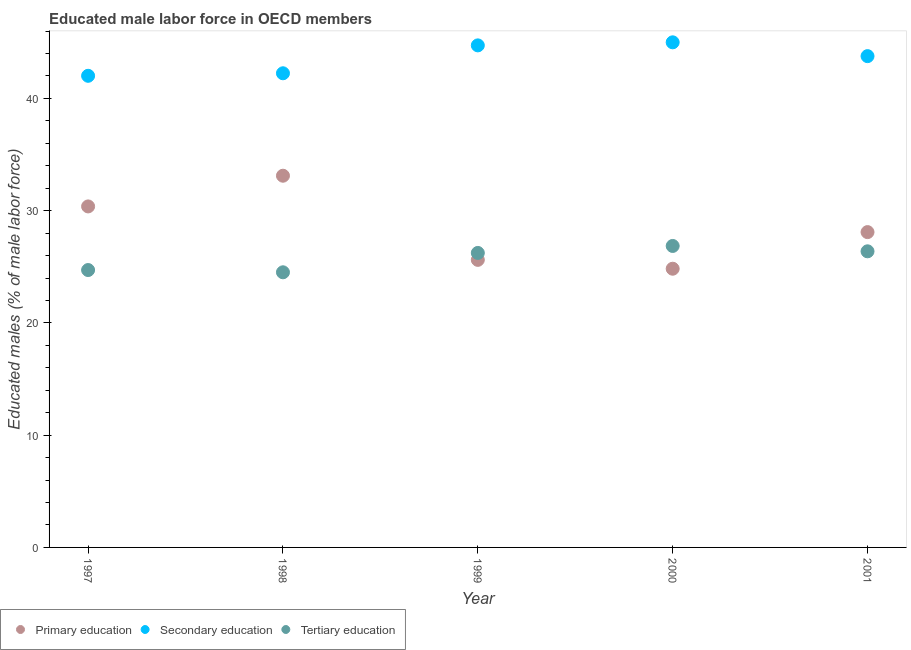What is the percentage of male labor force who received primary education in 1998?
Your answer should be very brief. 33.11. Across all years, what is the maximum percentage of male labor force who received secondary education?
Your response must be concise. 45. Across all years, what is the minimum percentage of male labor force who received tertiary education?
Ensure brevity in your answer.  24.51. What is the total percentage of male labor force who received tertiary education in the graph?
Offer a terse response. 128.69. What is the difference between the percentage of male labor force who received tertiary education in 1998 and that in 2000?
Provide a short and direct response. -2.35. What is the difference between the percentage of male labor force who received primary education in 2001 and the percentage of male labor force who received secondary education in 1999?
Offer a very short reply. -16.63. What is the average percentage of male labor force who received secondary education per year?
Your response must be concise. 43.55. In the year 2000, what is the difference between the percentage of male labor force who received secondary education and percentage of male labor force who received tertiary education?
Make the answer very short. 18.14. What is the ratio of the percentage of male labor force who received tertiary education in 1999 to that in 2000?
Ensure brevity in your answer.  0.98. What is the difference between the highest and the second highest percentage of male labor force who received tertiary education?
Keep it short and to the point. 0.48. What is the difference between the highest and the lowest percentage of male labor force who received primary education?
Make the answer very short. 8.28. In how many years, is the percentage of male labor force who received secondary education greater than the average percentage of male labor force who received secondary education taken over all years?
Offer a very short reply. 3. How many dotlines are there?
Offer a very short reply. 3. How many years are there in the graph?
Keep it short and to the point. 5. Does the graph contain any zero values?
Your answer should be very brief. No. Does the graph contain grids?
Provide a succinct answer. No. Where does the legend appear in the graph?
Provide a short and direct response. Bottom left. How many legend labels are there?
Offer a terse response. 3. How are the legend labels stacked?
Offer a very short reply. Horizontal. What is the title of the graph?
Your answer should be compact. Educated male labor force in OECD members. Does "Self-employed" appear as one of the legend labels in the graph?
Provide a succinct answer. No. What is the label or title of the X-axis?
Give a very brief answer. Year. What is the label or title of the Y-axis?
Provide a succinct answer. Educated males (% of male labor force). What is the Educated males (% of male labor force) of Primary education in 1997?
Your response must be concise. 30.38. What is the Educated males (% of male labor force) of Secondary education in 1997?
Your answer should be very brief. 42.01. What is the Educated males (% of male labor force) in Tertiary education in 1997?
Provide a succinct answer. 24.71. What is the Educated males (% of male labor force) of Primary education in 1998?
Your answer should be very brief. 33.11. What is the Educated males (% of male labor force) in Secondary education in 1998?
Provide a succinct answer. 42.24. What is the Educated males (% of male labor force) in Tertiary education in 1998?
Make the answer very short. 24.51. What is the Educated males (% of male labor force) in Primary education in 1999?
Offer a very short reply. 25.62. What is the Educated males (% of male labor force) in Secondary education in 1999?
Your response must be concise. 44.72. What is the Educated males (% of male labor force) of Tertiary education in 1999?
Keep it short and to the point. 26.23. What is the Educated males (% of male labor force) of Primary education in 2000?
Offer a very short reply. 24.83. What is the Educated males (% of male labor force) in Secondary education in 2000?
Make the answer very short. 45. What is the Educated males (% of male labor force) of Tertiary education in 2000?
Ensure brevity in your answer.  26.85. What is the Educated males (% of male labor force) in Primary education in 2001?
Offer a very short reply. 28.09. What is the Educated males (% of male labor force) in Secondary education in 2001?
Provide a short and direct response. 43.76. What is the Educated males (% of male labor force) of Tertiary education in 2001?
Offer a terse response. 26.38. Across all years, what is the maximum Educated males (% of male labor force) in Primary education?
Your response must be concise. 33.11. Across all years, what is the maximum Educated males (% of male labor force) in Secondary education?
Your answer should be very brief. 45. Across all years, what is the maximum Educated males (% of male labor force) in Tertiary education?
Offer a very short reply. 26.85. Across all years, what is the minimum Educated males (% of male labor force) of Primary education?
Your answer should be very brief. 24.83. Across all years, what is the minimum Educated males (% of male labor force) in Secondary education?
Make the answer very short. 42.01. Across all years, what is the minimum Educated males (% of male labor force) in Tertiary education?
Your answer should be very brief. 24.51. What is the total Educated males (% of male labor force) of Primary education in the graph?
Provide a short and direct response. 142.02. What is the total Educated males (% of male labor force) of Secondary education in the graph?
Ensure brevity in your answer.  217.73. What is the total Educated males (% of male labor force) of Tertiary education in the graph?
Provide a succinct answer. 128.69. What is the difference between the Educated males (% of male labor force) in Primary education in 1997 and that in 1998?
Your answer should be very brief. -2.73. What is the difference between the Educated males (% of male labor force) of Secondary education in 1997 and that in 1998?
Your answer should be compact. -0.22. What is the difference between the Educated males (% of male labor force) in Tertiary education in 1997 and that in 1998?
Your answer should be compact. 0.2. What is the difference between the Educated males (% of male labor force) of Primary education in 1997 and that in 1999?
Provide a short and direct response. 4.76. What is the difference between the Educated males (% of male labor force) of Secondary education in 1997 and that in 1999?
Make the answer very short. -2.71. What is the difference between the Educated males (% of male labor force) of Tertiary education in 1997 and that in 1999?
Offer a terse response. -1.52. What is the difference between the Educated males (% of male labor force) in Primary education in 1997 and that in 2000?
Make the answer very short. 5.55. What is the difference between the Educated males (% of male labor force) in Secondary education in 1997 and that in 2000?
Your response must be concise. -2.98. What is the difference between the Educated males (% of male labor force) of Tertiary education in 1997 and that in 2000?
Give a very brief answer. -2.14. What is the difference between the Educated males (% of male labor force) of Primary education in 1997 and that in 2001?
Provide a short and direct response. 2.29. What is the difference between the Educated males (% of male labor force) in Secondary education in 1997 and that in 2001?
Offer a very short reply. -1.75. What is the difference between the Educated males (% of male labor force) in Tertiary education in 1997 and that in 2001?
Offer a terse response. -1.67. What is the difference between the Educated males (% of male labor force) in Primary education in 1998 and that in 1999?
Offer a terse response. 7.5. What is the difference between the Educated males (% of male labor force) in Secondary education in 1998 and that in 1999?
Ensure brevity in your answer.  -2.49. What is the difference between the Educated males (% of male labor force) in Tertiary education in 1998 and that in 1999?
Ensure brevity in your answer.  -1.72. What is the difference between the Educated males (% of male labor force) in Primary education in 1998 and that in 2000?
Offer a very short reply. 8.28. What is the difference between the Educated males (% of male labor force) of Secondary education in 1998 and that in 2000?
Ensure brevity in your answer.  -2.76. What is the difference between the Educated males (% of male labor force) in Tertiary education in 1998 and that in 2000?
Your response must be concise. -2.35. What is the difference between the Educated males (% of male labor force) of Primary education in 1998 and that in 2001?
Ensure brevity in your answer.  5.02. What is the difference between the Educated males (% of male labor force) in Secondary education in 1998 and that in 2001?
Your answer should be compact. -1.53. What is the difference between the Educated males (% of male labor force) in Tertiary education in 1998 and that in 2001?
Make the answer very short. -1.87. What is the difference between the Educated males (% of male labor force) of Primary education in 1999 and that in 2000?
Your response must be concise. 0.79. What is the difference between the Educated males (% of male labor force) of Secondary education in 1999 and that in 2000?
Give a very brief answer. -0.27. What is the difference between the Educated males (% of male labor force) in Tertiary education in 1999 and that in 2000?
Offer a very short reply. -0.62. What is the difference between the Educated males (% of male labor force) in Primary education in 1999 and that in 2001?
Give a very brief answer. -2.47. What is the difference between the Educated males (% of male labor force) in Secondary education in 1999 and that in 2001?
Make the answer very short. 0.96. What is the difference between the Educated males (% of male labor force) in Tertiary education in 1999 and that in 2001?
Make the answer very short. -0.14. What is the difference between the Educated males (% of male labor force) in Primary education in 2000 and that in 2001?
Provide a short and direct response. -3.26. What is the difference between the Educated males (% of male labor force) in Secondary education in 2000 and that in 2001?
Your answer should be very brief. 1.23. What is the difference between the Educated males (% of male labor force) in Tertiary education in 2000 and that in 2001?
Offer a terse response. 0.48. What is the difference between the Educated males (% of male labor force) of Primary education in 1997 and the Educated males (% of male labor force) of Secondary education in 1998?
Your response must be concise. -11.86. What is the difference between the Educated males (% of male labor force) of Primary education in 1997 and the Educated males (% of male labor force) of Tertiary education in 1998?
Your answer should be very brief. 5.87. What is the difference between the Educated males (% of male labor force) in Secondary education in 1997 and the Educated males (% of male labor force) in Tertiary education in 1998?
Your answer should be very brief. 17.5. What is the difference between the Educated males (% of male labor force) in Primary education in 1997 and the Educated males (% of male labor force) in Secondary education in 1999?
Offer a very short reply. -14.35. What is the difference between the Educated males (% of male labor force) in Primary education in 1997 and the Educated males (% of male labor force) in Tertiary education in 1999?
Provide a succinct answer. 4.14. What is the difference between the Educated males (% of male labor force) in Secondary education in 1997 and the Educated males (% of male labor force) in Tertiary education in 1999?
Provide a succinct answer. 15.78. What is the difference between the Educated males (% of male labor force) in Primary education in 1997 and the Educated males (% of male labor force) in Secondary education in 2000?
Keep it short and to the point. -14.62. What is the difference between the Educated males (% of male labor force) in Primary education in 1997 and the Educated males (% of male labor force) in Tertiary education in 2000?
Your response must be concise. 3.52. What is the difference between the Educated males (% of male labor force) in Secondary education in 1997 and the Educated males (% of male labor force) in Tertiary education in 2000?
Offer a very short reply. 15.16. What is the difference between the Educated males (% of male labor force) in Primary education in 1997 and the Educated males (% of male labor force) in Secondary education in 2001?
Your response must be concise. -13.39. What is the difference between the Educated males (% of male labor force) of Primary education in 1997 and the Educated males (% of male labor force) of Tertiary education in 2001?
Ensure brevity in your answer.  4. What is the difference between the Educated males (% of male labor force) of Secondary education in 1997 and the Educated males (% of male labor force) of Tertiary education in 2001?
Your answer should be very brief. 15.63. What is the difference between the Educated males (% of male labor force) in Primary education in 1998 and the Educated males (% of male labor force) in Secondary education in 1999?
Keep it short and to the point. -11.61. What is the difference between the Educated males (% of male labor force) in Primary education in 1998 and the Educated males (% of male labor force) in Tertiary education in 1999?
Ensure brevity in your answer.  6.88. What is the difference between the Educated males (% of male labor force) of Secondary education in 1998 and the Educated males (% of male labor force) of Tertiary education in 1999?
Your response must be concise. 16. What is the difference between the Educated males (% of male labor force) in Primary education in 1998 and the Educated males (% of male labor force) in Secondary education in 2000?
Your response must be concise. -11.88. What is the difference between the Educated males (% of male labor force) in Primary education in 1998 and the Educated males (% of male labor force) in Tertiary education in 2000?
Offer a very short reply. 6.26. What is the difference between the Educated males (% of male labor force) in Secondary education in 1998 and the Educated males (% of male labor force) in Tertiary education in 2000?
Offer a terse response. 15.38. What is the difference between the Educated males (% of male labor force) of Primary education in 1998 and the Educated males (% of male labor force) of Secondary education in 2001?
Your answer should be compact. -10.65. What is the difference between the Educated males (% of male labor force) of Primary education in 1998 and the Educated males (% of male labor force) of Tertiary education in 2001?
Provide a succinct answer. 6.73. What is the difference between the Educated males (% of male labor force) of Secondary education in 1998 and the Educated males (% of male labor force) of Tertiary education in 2001?
Make the answer very short. 15.86. What is the difference between the Educated males (% of male labor force) of Primary education in 1999 and the Educated males (% of male labor force) of Secondary education in 2000?
Provide a short and direct response. -19.38. What is the difference between the Educated males (% of male labor force) of Primary education in 1999 and the Educated males (% of male labor force) of Tertiary education in 2000?
Your answer should be very brief. -1.24. What is the difference between the Educated males (% of male labor force) of Secondary education in 1999 and the Educated males (% of male labor force) of Tertiary education in 2000?
Keep it short and to the point. 17.87. What is the difference between the Educated males (% of male labor force) in Primary education in 1999 and the Educated males (% of male labor force) in Secondary education in 2001?
Offer a very short reply. -18.15. What is the difference between the Educated males (% of male labor force) in Primary education in 1999 and the Educated males (% of male labor force) in Tertiary education in 2001?
Your answer should be compact. -0.76. What is the difference between the Educated males (% of male labor force) of Secondary education in 1999 and the Educated males (% of male labor force) of Tertiary education in 2001?
Offer a very short reply. 18.34. What is the difference between the Educated males (% of male labor force) of Primary education in 2000 and the Educated males (% of male labor force) of Secondary education in 2001?
Offer a very short reply. -18.94. What is the difference between the Educated males (% of male labor force) of Primary education in 2000 and the Educated males (% of male labor force) of Tertiary education in 2001?
Your answer should be compact. -1.55. What is the difference between the Educated males (% of male labor force) of Secondary education in 2000 and the Educated males (% of male labor force) of Tertiary education in 2001?
Offer a terse response. 18.62. What is the average Educated males (% of male labor force) of Primary education per year?
Ensure brevity in your answer.  28.4. What is the average Educated males (% of male labor force) in Secondary education per year?
Ensure brevity in your answer.  43.55. What is the average Educated males (% of male labor force) in Tertiary education per year?
Make the answer very short. 25.74. In the year 1997, what is the difference between the Educated males (% of male labor force) of Primary education and Educated males (% of male labor force) of Secondary education?
Provide a succinct answer. -11.64. In the year 1997, what is the difference between the Educated males (% of male labor force) in Primary education and Educated males (% of male labor force) in Tertiary education?
Your answer should be compact. 5.67. In the year 1997, what is the difference between the Educated males (% of male labor force) in Secondary education and Educated males (% of male labor force) in Tertiary education?
Your answer should be very brief. 17.3. In the year 1998, what is the difference between the Educated males (% of male labor force) in Primary education and Educated males (% of male labor force) in Secondary education?
Your answer should be compact. -9.13. In the year 1998, what is the difference between the Educated males (% of male labor force) in Primary education and Educated males (% of male labor force) in Tertiary education?
Your response must be concise. 8.6. In the year 1998, what is the difference between the Educated males (% of male labor force) in Secondary education and Educated males (% of male labor force) in Tertiary education?
Offer a terse response. 17.73. In the year 1999, what is the difference between the Educated males (% of male labor force) in Primary education and Educated males (% of male labor force) in Secondary education?
Ensure brevity in your answer.  -19.11. In the year 1999, what is the difference between the Educated males (% of male labor force) of Primary education and Educated males (% of male labor force) of Tertiary education?
Offer a very short reply. -0.62. In the year 1999, what is the difference between the Educated males (% of male labor force) of Secondary education and Educated males (% of male labor force) of Tertiary education?
Your answer should be compact. 18.49. In the year 2000, what is the difference between the Educated males (% of male labor force) of Primary education and Educated males (% of male labor force) of Secondary education?
Your answer should be very brief. -20.17. In the year 2000, what is the difference between the Educated males (% of male labor force) in Primary education and Educated males (% of male labor force) in Tertiary education?
Ensure brevity in your answer.  -2.03. In the year 2000, what is the difference between the Educated males (% of male labor force) of Secondary education and Educated males (% of male labor force) of Tertiary education?
Give a very brief answer. 18.14. In the year 2001, what is the difference between the Educated males (% of male labor force) of Primary education and Educated males (% of male labor force) of Secondary education?
Your answer should be compact. -15.68. In the year 2001, what is the difference between the Educated males (% of male labor force) of Primary education and Educated males (% of male labor force) of Tertiary education?
Keep it short and to the point. 1.71. In the year 2001, what is the difference between the Educated males (% of male labor force) in Secondary education and Educated males (% of male labor force) in Tertiary education?
Offer a terse response. 17.39. What is the ratio of the Educated males (% of male labor force) of Primary education in 1997 to that in 1998?
Offer a very short reply. 0.92. What is the ratio of the Educated males (% of male labor force) of Secondary education in 1997 to that in 1998?
Keep it short and to the point. 0.99. What is the ratio of the Educated males (% of male labor force) of Tertiary education in 1997 to that in 1998?
Provide a short and direct response. 1.01. What is the ratio of the Educated males (% of male labor force) in Primary education in 1997 to that in 1999?
Provide a short and direct response. 1.19. What is the ratio of the Educated males (% of male labor force) in Secondary education in 1997 to that in 1999?
Your answer should be very brief. 0.94. What is the ratio of the Educated males (% of male labor force) in Tertiary education in 1997 to that in 1999?
Your answer should be very brief. 0.94. What is the ratio of the Educated males (% of male labor force) of Primary education in 1997 to that in 2000?
Keep it short and to the point. 1.22. What is the ratio of the Educated males (% of male labor force) of Secondary education in 1997 to that in 2000?
Make the answer very short. 0.93. What is the ratio of the Educated males (% of male labor force) in Tertiary education in 1997 to that in 2000?
Give a very brief answer. 0.92. What is the ratio of the Educated males (% of male labor force) in Primary education in 1997 to that in 2001?
Make the answer very short. 1.08. What is the ratio of the Educated males (% of male labor force) of Tertiary education in 1997 to that in 2001?
Provide a short and direct response. 0.94. What is the ratio of the Educated males (% of male labor force) of Primary education in 1998 to that in 1999?
Offer a terse response. 1.29. What is the ratio of the Educated males (% of male labor force) of Tertiary education in 1998 to that in 1999?
Keep it short and to the point. 0.93. What is the ratio of the Educated males (% of male labor force) in Primary education in 1998 to that in 2000?
Your answer should be very brief. 1.33. What is the ratio of the Educated males (% of male labor force) in Secondary education in 1998 to that in 2000?
Your answer should be very brief. 0.94. What is the ratio of the Educated males (% of male labor force) of Tertiary education in 1998 to that in 2000?
Offer a terse response. 0.91. What is the ratio of the Educated males (% of male labor force) of Primary education in 1998 to that in 2001?
Provide a short and direct response. 1.18. What is the ratio of the Educated males (% of male labor force) of Secondary education in 1998 to that in 2001?
Make the answer very short. 0.97. What is the ratio of the Educated males (% of male labor force) of Tertiary education in 1998 to that in 2001?
Give a very brief answer. 0.93. What is the ratio of the Educated males (% of male labor force) in Primary education in 1999 to that in 2000?
Offer a very short reply. 1.03. What is the ratio of the Educated males (% of male labor force) in Tertiary education in 1999 to that in 2000?
Offer a very short reply. 0.98. What is the ratio of the Educated males (% of male labor force) in Primary education in 1999 to that in 2001?
Provide a succinct answer. 0.91. What is the ratio of the Educated males (% of male labor force) of Secondary education in 1999 to that in 2001?
Your answer should be very brief. 1.02. What is the ratio of the Educated males (% of male labor force) of Primary education in 2000 to that in 2001?
Offer a terse response. 0.88. What is the ratio of the Educated males (% of male labor force) of Secondary education in 2000 to that in 2001?
Offer a terse response. 1.03. What is the ratio of the Educated males (% of male labor force) of Tertiary education in 2000 to that in 2001?
Provide a short and direct response. 1.02. What is the difference between the highest and the second highest Educated males (% of male labor force) in Primary education?
Provide a succinct answer. 2.73. What is the difference between the highest and the second highest Educated males (% of male labor force) of Secondary education?
Provide a short and direct response. 0.27. What is the difference between the highest and the second highest Educated males (% of male labor force) of Tertiary education?
Offer a very short reply. 0.48. What is the difference between the highest and the lowest Educated males (% of male labor force) of Primary education?
Your answer should be compact. 8.28. What is the difference between the highest and the lowest Educated males (% of male labor force) of Secondary education?
Provide a short and direct response. 2.98. What is the difference between the highest and the lowest Educated males (% of male labor force) in Tertiary education?
Your answer should be very brief. 2.35. 